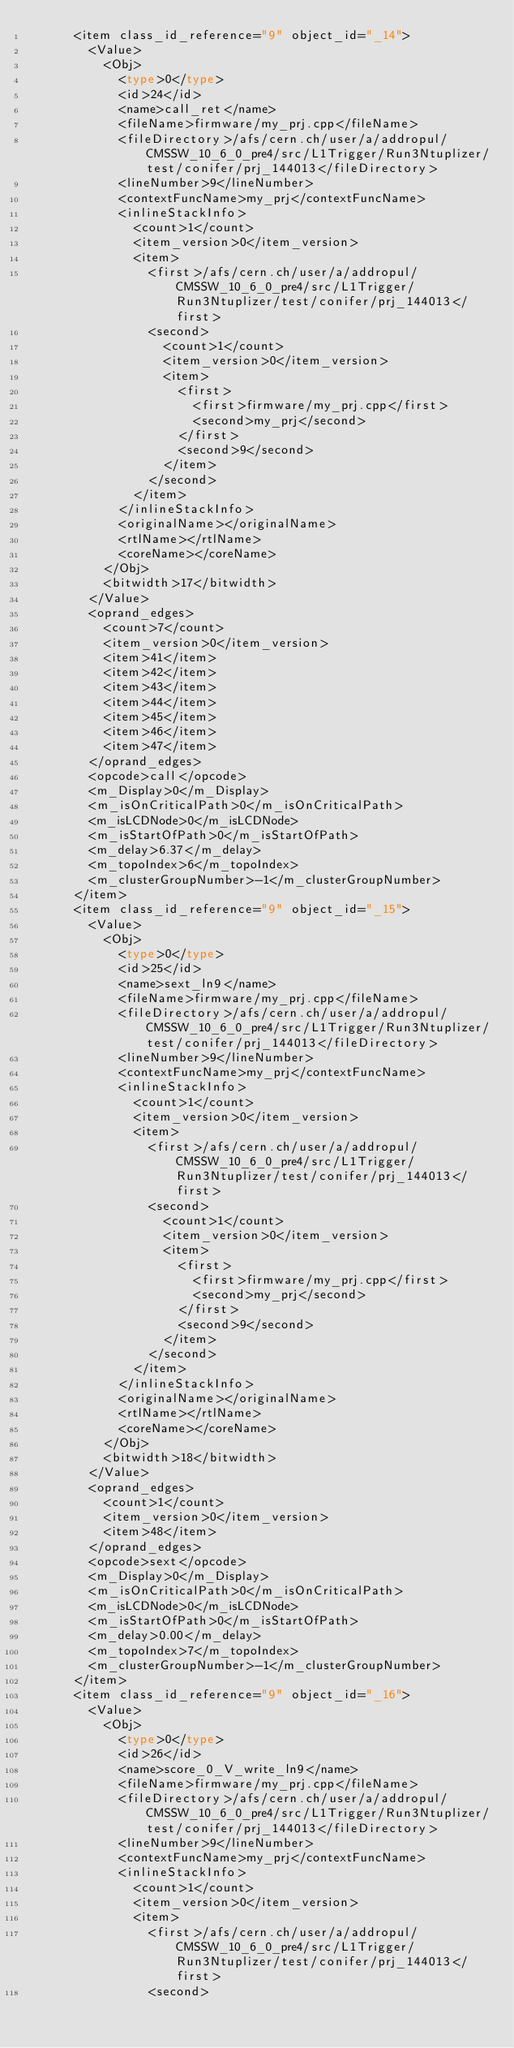<code> <loc_0><loc_0><loc_500><loc_500><_Ada_>			<item class_id_reference="9" object_id="_14">
				<Value>
					<Obj>
						<type>0</type>
						<id>24</id>
						<name>call_ret</name>
						<fileName>firmware/my_prj.cpp</fileName>
						<fileDirectory>/afs/cern.ch/user/a/addropul/CMSSW_10_6_0_pre4/src/L1Trigger/Run3Ntuplizer/test/conifer/prj_144013</fileDirectory>
						<lineNumber>9</lineNumber>
						<contextFuncName>my_prj</contextFuncName>
						<inlineStackInfo>
							<count>1</count>
							<item_version>0</item_version>
							<item>
								<first>/afs/cern.ch/user/a/addropul/CMSSW_10_6_0_pre4/src/L1Trigger/Run3Ntuplizer/test/conifer/prj_144013</first>
								<second>
									<count>1</count>
									<item_version>0</item_version>
									<item>
										<first>
											<first>firmware/my_prj.cpp</first>
											<second>my_prj</second>
										</first>
										<second>9</second>
									</item>
								</second>
							</item>
						</inlineStackInfo>
						<originalName></originalName>
						<rtlName></rtlName>
						<coreName></coreName>
					</Obj>
					<bitwidth>17</bitwidth>
				</Value>
				<oprand_edges>
					<count>7</count>
					<item_version>0</item_version>
					<item>41</item>
					<item>42</item>
					<item>43</item>
					<item>44</item>
					<item>45</item>
					<item>46</item>
					<item>47</item>
				</oprand_edges>
				<opcode>call</opcode>
				<m_Display>0</m_Display>
				<m_isOnCriticalPath>0</m_isOnCriticalPath>
				<m_isLCDNode>0</m_isLCDNode>
				<m_isStartOfPath>0</m_isStartOfPath>
				<m_delay>6.37</m_delay>
				<m_topoIndex>6</m_topoIndex>
				<m_clusterGroupNumber>-1</m_clusterGroupNumber>
			</item>
			<item class_id_reference="9" object_id="_15">
				<Value>
					<Obj>
						<type>0</type>
						<id>25</id>
						<name>sext_ln9</name>
						<fileName>firmware/my_prj.cpp</fileName>
						<fileDirectory>/afs/cern.ch/user/a/addropul/CMSSW_10_6_0_pre4/src/L1Trigger/Run3Ntuplizer/test/conifer/prj_144013</fileDirectory>
						<lineNumber>9</lineNumber>
						<contextFuncName>my_prj</contextFuncName>
						<inlineStackInfo>
							<count>1</count>
							<item_version>0</item_version>
							<item>
								<first>/afs/cern.ch/user/a/addropul/CMSSW_10_6_0_pre4/src/L1Trigger/Run3Ntuplizer/test/conifer/prj_144013</first>
								<second>
									<count>1</count>
									<item_version>0</item_version>
									<item>
										<first>
											<first>firmware/my_prj.cpp</first>
											<second>my_prj</second>
										</first>
										<second>9</second>
									</item>
								</second>
							</item>
						</inlineStackInfo>
						<originalName></originalName>
						<rtlName></rtlName>
						<coreName></coreName>
					</Obj>
					<bitwidth>18</bitwidth>
				</Value>
				<oprand_edges>
					<count>1</count>
					<item_version>0</item_version>
					<item>48</item>
				</oprand_edges>
				<opcode>sext</opcode>
				<m_Display>0</m_Display>
				<m_isOnCriticalPath>0</m_isOnCriticalPath>
				<m_isLCDNode>0</m_isLCDNode>
				<m_isStartOfPath>0</m_isStartOfPath>
				<m_delay>0.00</m_delay>
				<m_topoIndex>7</m_topoIndex>
				<m_clusterGroupNumber>-1</m_clusterGroupNumber>
			</item>
			<item class_id_reference="9" object_id="_16">
				<Value>
					<Obj>
						<type>0</type>
						<id>26</id>
						<name>score_0_V_write_ln9</name>
						<fileName>firmware/my_prj.cpp</fileName>
						<fileDirectory>/afs/cern.ch/user/a/addropul/CMSSW_10_6_0_pre4/src/L1Trigger/Run3Ntuplizer/test/conifer/prj_144013</fileDirectory>
						<lineNumber>9</lineNumber>
						<contextFuncName>my_prj</contextFuncName>
						<inlineStackInfo>
							<count>1</count>
							<item_version>0</item_version>
							<item>
								<first>/afs/cern.ch/user/a/addropul/CMSSW_10_6_0_pre4/src/L1Trigger/Run3Ntuplizer/test/conifer/prj_144013</first>
								<second></code> 